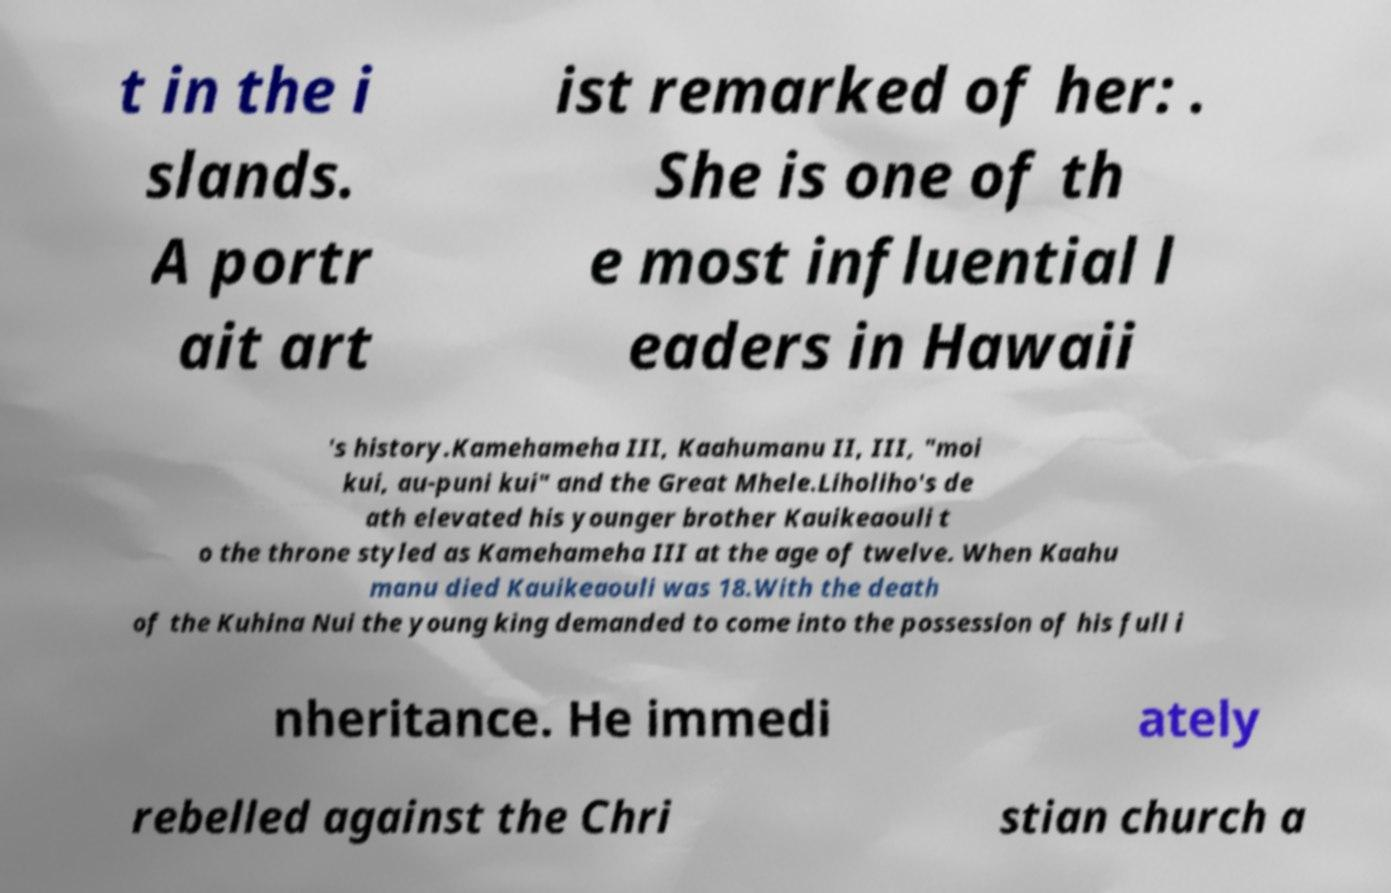What messages or text are displayed in this image? I need them in a readable, typed format. t in the i slands. A portr ait art ist remarked of her: . She is one of th e most influential l eaders in Hawaii 's history.Kamehameha III, Kaahumanu II, III, "moi kui, au-puni kui" and the Great Mhele.Liholiho's de ath elevated his younger brother Kauikeaouli t o the throne styled as Kamehameha III at the age of twelve. When Kaahu manu died Kauikeaouli was 18.With the death of the Kuhina Nui the young king demanded to come into the possession of his full i nheritance. He immedi ately rebelled against the Chri stian church a 